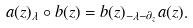Convert formula to latex. <formula><loc_0><loc_0><loc_500><loc_500>a ( z ) _ { \lambda } \circ b ( z ) = b ( z ) _ { - \lambda - \partial _ { z } } a ( z ) .</formula> 